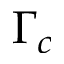<formula> <loc_0><loc_0><loc_500><loc_500>\Gamma _ { c }</formula> 